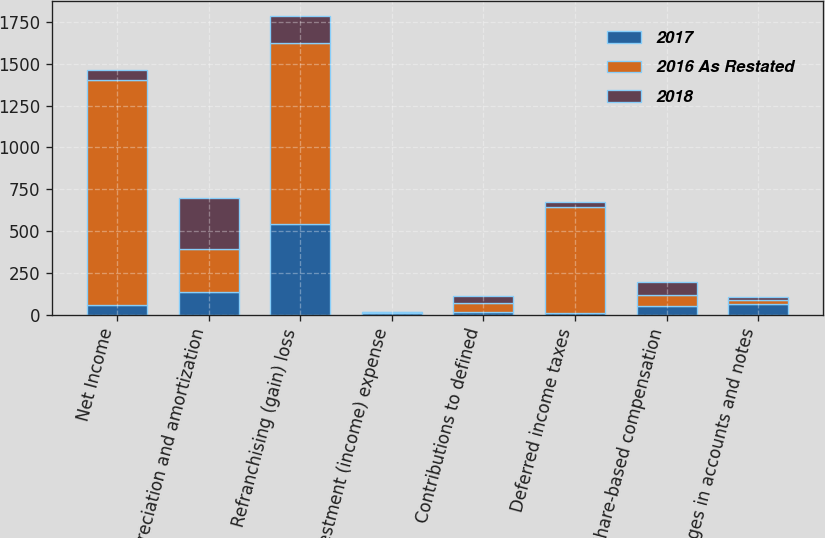Convert chart to OTSL. <chart><loc_0><loc_0><loc_500><loc_500><stacked_bar_chart><ecel><fcel>Net Income<fcel>Depreciation and amortization<fcel>Refranchising (gain) loss<fcel>Investment (income) expense<fcel>Contributions to defined<fcel>Deferred income taxes<fcel>Share-based compensation<fcel>Changes in accounts and notes<nl><fcel>2017<fcel>60<fcel>137<fcel>540<fcel>9<fcel>16<fcel>11<fcel>50<fcel>66<nl><fcel>2016 As Restated<fcel>1340<fcel>253<fcel>1083<fcel>5<fcel>55<fcel>634<fcel>65<fcel>19<nl><fcel>2018<fcel>60<fcel>310<fcel>163<fcel>2<fcel>41<fcel>28<fcel>80<fcel>23<nl></chart> 